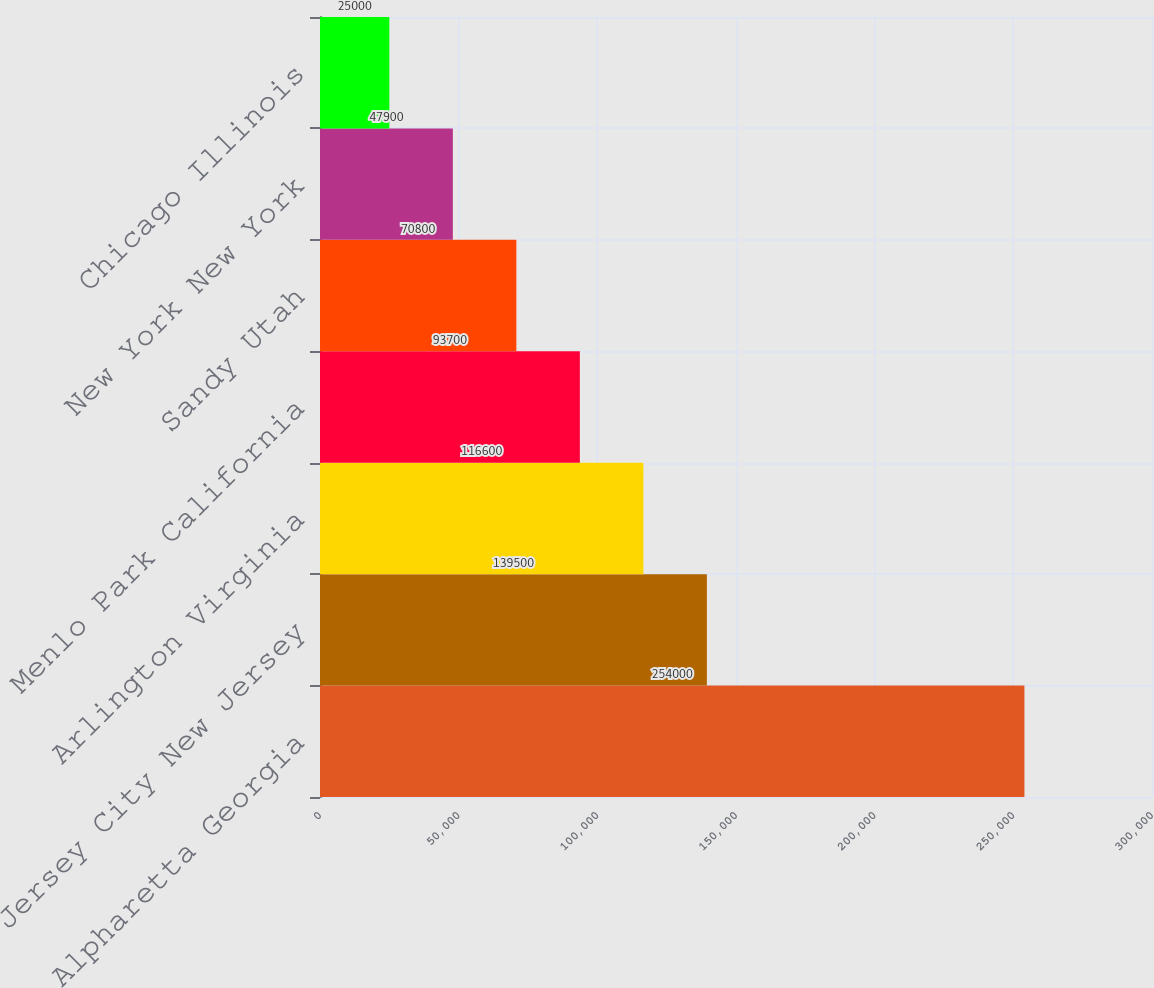Convert chart to OTSL. <chart><loc_0><loc_0><loc_500><loc_500><bar_chart><fcel>Alpharetta Georgia<fcel>Jersey City New Jersey<fcel>Arlington Virginia<fcel>Menlo Park California<fcel>Sandy Utah<fcel>New York New York<fcel>Chicago Illinois<nl><fcel>254000<fcel>139500<fcel>116600<fcel>93700<fcel>70800<fcel>47900<fcel>25000<nl></chart> 